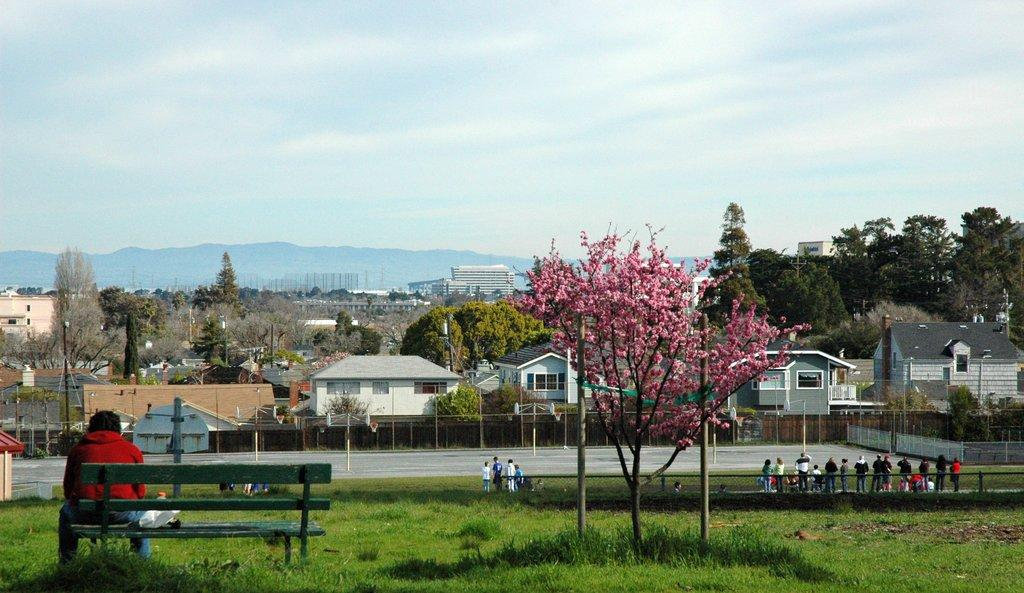What type of structures can be seen in the image? There are houses in the image. What other natural elements are present in the image? There are trees in the image. How would you describe the sky in the image? The sky is blue and cloudy in the image. Can you identify any people in the image? Yes, there is a person seated on a bench and people standing in the image. What else can be seen in the image? There is a road visible in the image. How does the person seated on the bench care for their stomach in the image? There is no information about the person's stomach or any actions related to it in the image. Is there an exchange happening between the people standing in the image? There is no indication of an exchange or any interaction between the people standing in the image. 